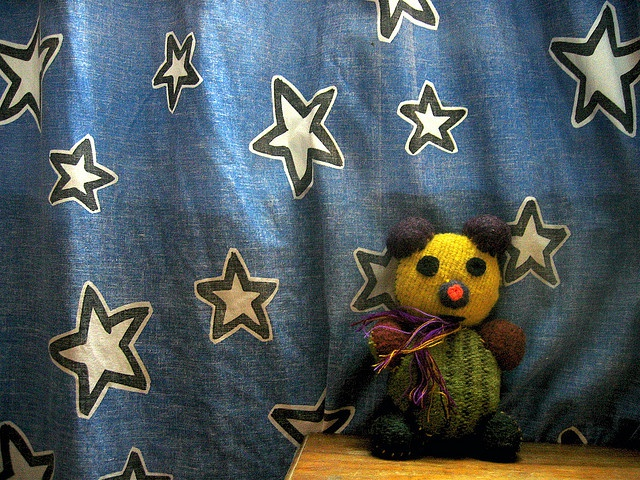Describe the objects in this image and their specific colors. I can see a teddy bear in darkblue, black, olive, and maroon tones in this image. 